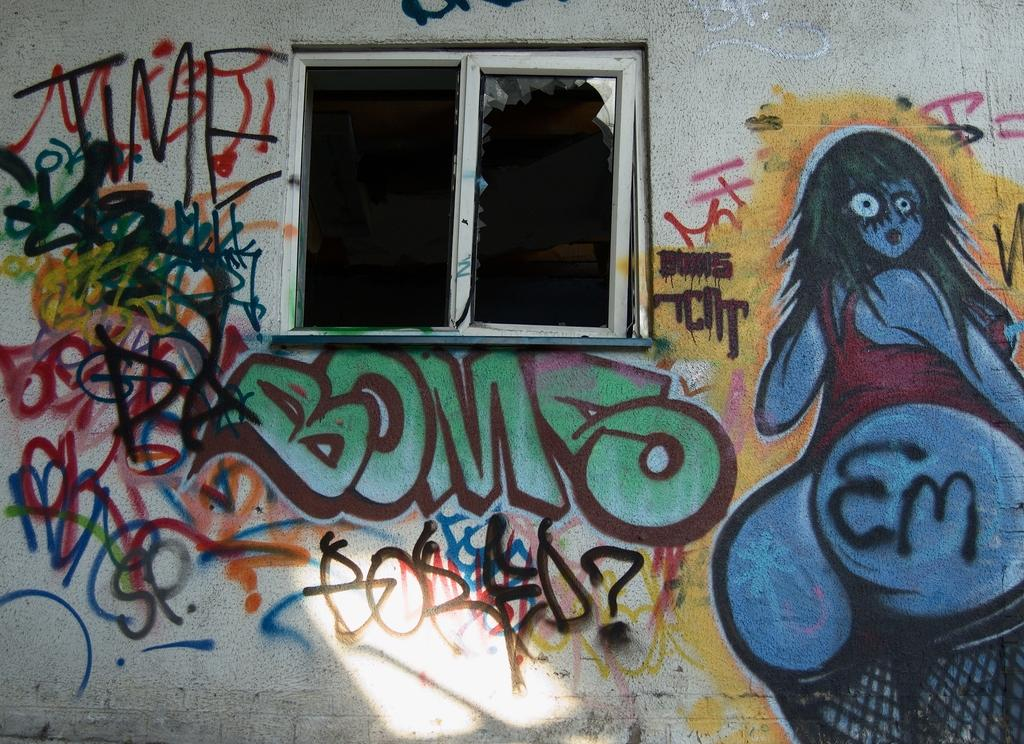What type of structure can be seen in the image? There is a wall in the image. Is there any opening in the wall? Yes, there is a window in the image. What is on the wall? Graffiti art is present on the wall. How would you describe the graffiti art? The graffiti art consists of different colors on a white background. Where is the faucet located in the image? There is no faucet present in the image. What type of bears are depicted in the graffiti art? There are no bears depicted in the graffiti art; it consists of different colors on a white background. 